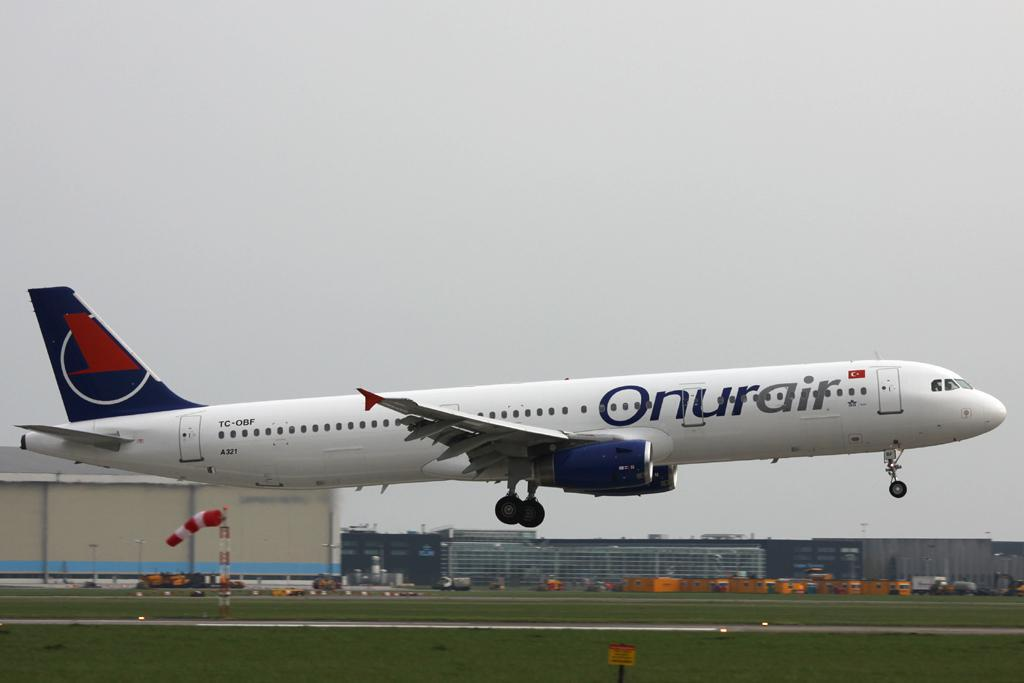Provide a one-sentence caption for the provided image. A large Onurair passenger jet almost landed at an airport. 